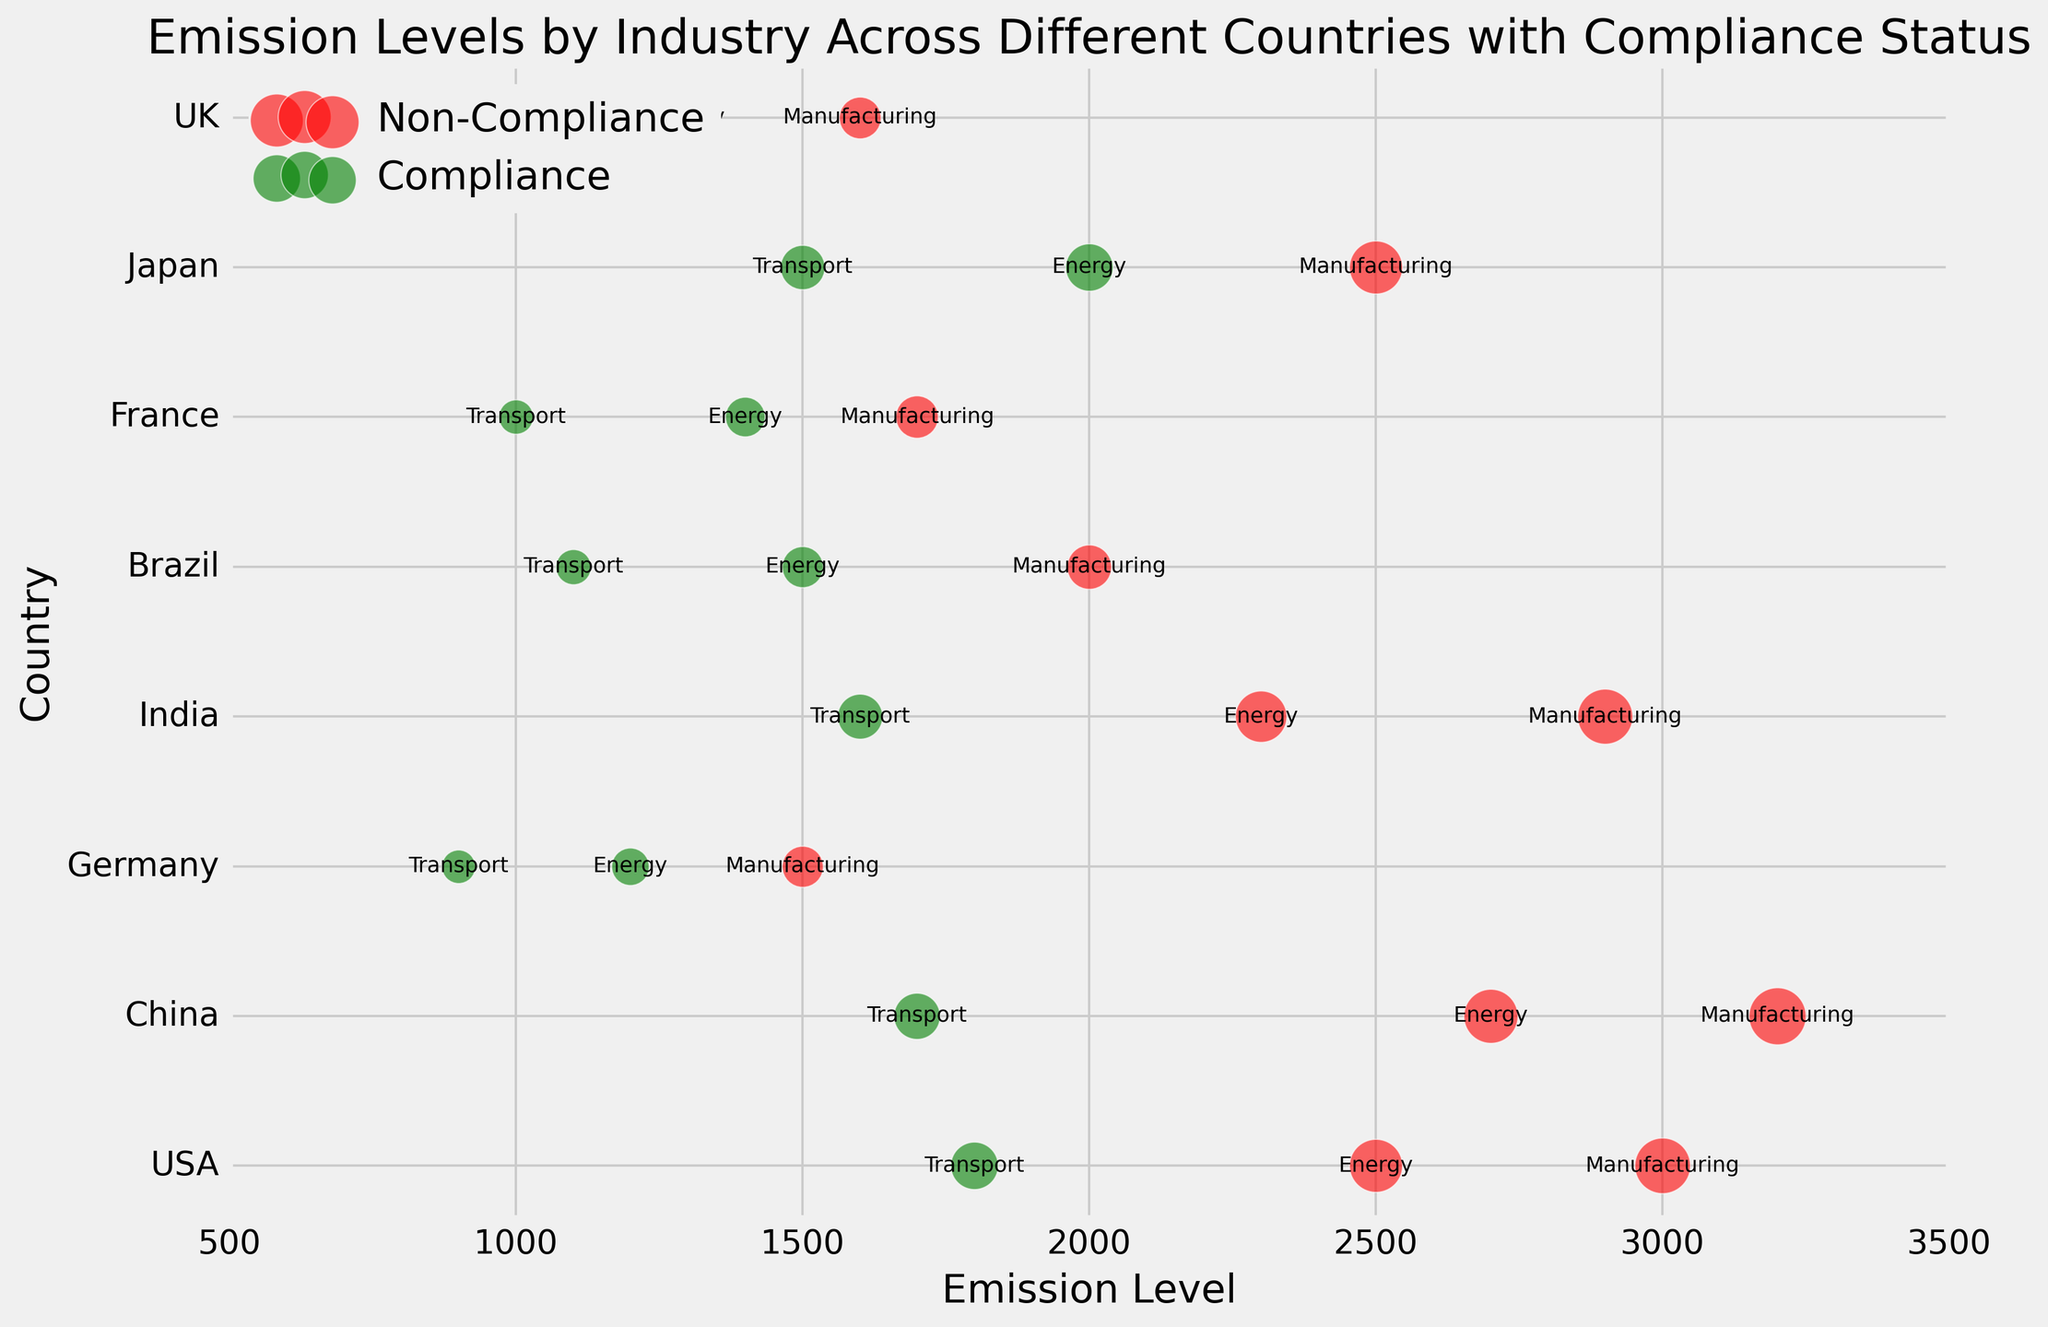Which country has the highest emission level in the manufacturing industry? First, find 'Manufacturing' under the 'Industry' column for each country. Then, compare the 'EmissionLevel' values of these entries. China has the highest emission level in manufacturing with 3200.
Answer: China Which country has the most industries in compliance? Identify 'Compliance' entries in the 'ComplianceStatus' column for each country. Count these entries for each country. Germany has three entries under Compliance, which is the highest.
Answer: Germany How many countries have energy industries in non-compliance status? Locate 'Non-Compliance' under 'ComplianceStatus' within the 'Energy' industry. Count these instances. Four countries (USA, China, India, and Germany) have non-compliant Energy industries.
Answer: 4 What's the total emission level for compliant industries in Brazil? Identify 'Compliance' entries for Brazil. Sum their 'EmissionLevel' values (Energy: 1500, Transport: 1100). The total is 1500 + 1100 = 2600.
Answer: 2600 Which industry in the UK has the highest emission level? Look for the UK entries and compare their 'EmissionLevel' values. The Manufacturing industry has the highest emission level at 1600.
Answer: Manufacturing How does the emission level of India's energy industry compare to that of the USA's energy industry? Identify 'EmissionLevel' for Energy in both India and the USA. India's Energy emission is 2300; the USA's is 2500. The USA has a higher emission level.
Answer: The USA's emission level is higher What is the average emission level of the transport industry across all countries? Extract 'EmissionLevel' values for the Transport industry across all countries (1800, 1700, 900, 1600, 1100, 1000, 1500, 900). Sum these values (1800 + 1700 + 900 + 1600 + 1100 + 1000 + 1500 + 900 = 10500). Divide by the number of entries (8). The average is 10500/8 = 1312.5.
Answer: 1312.5 Which compliance status has the largest bubble size in Japan, and which industry does it belong to? Find Japan's entries in the dataset. Compare 'BubbleSize' values. The largest bubble size is 50, which belongs to 'Manufacturing' with a 'Non-Compliance' status.
Answer: Non-Compliance, Manufacturing What is the difference in emission levels between the energy industry in France and the energy industry in the UK? Identify 'EmissionLevel' for Energy in both France and the UK. France's Energy emission is 1400; the UK's is 1300. The difference is 1400 - 1300 = 100.
Answer: 100 Which country has the lowest emission level in any industry and what is the emission level? Search for the lowest value under 'EmissionLevel' across all industries and find the corresponding country and industry. The lowest emission level is 900 in both the Transport industry of Germany and the UK.
Answer: Germany and the UK, 900 